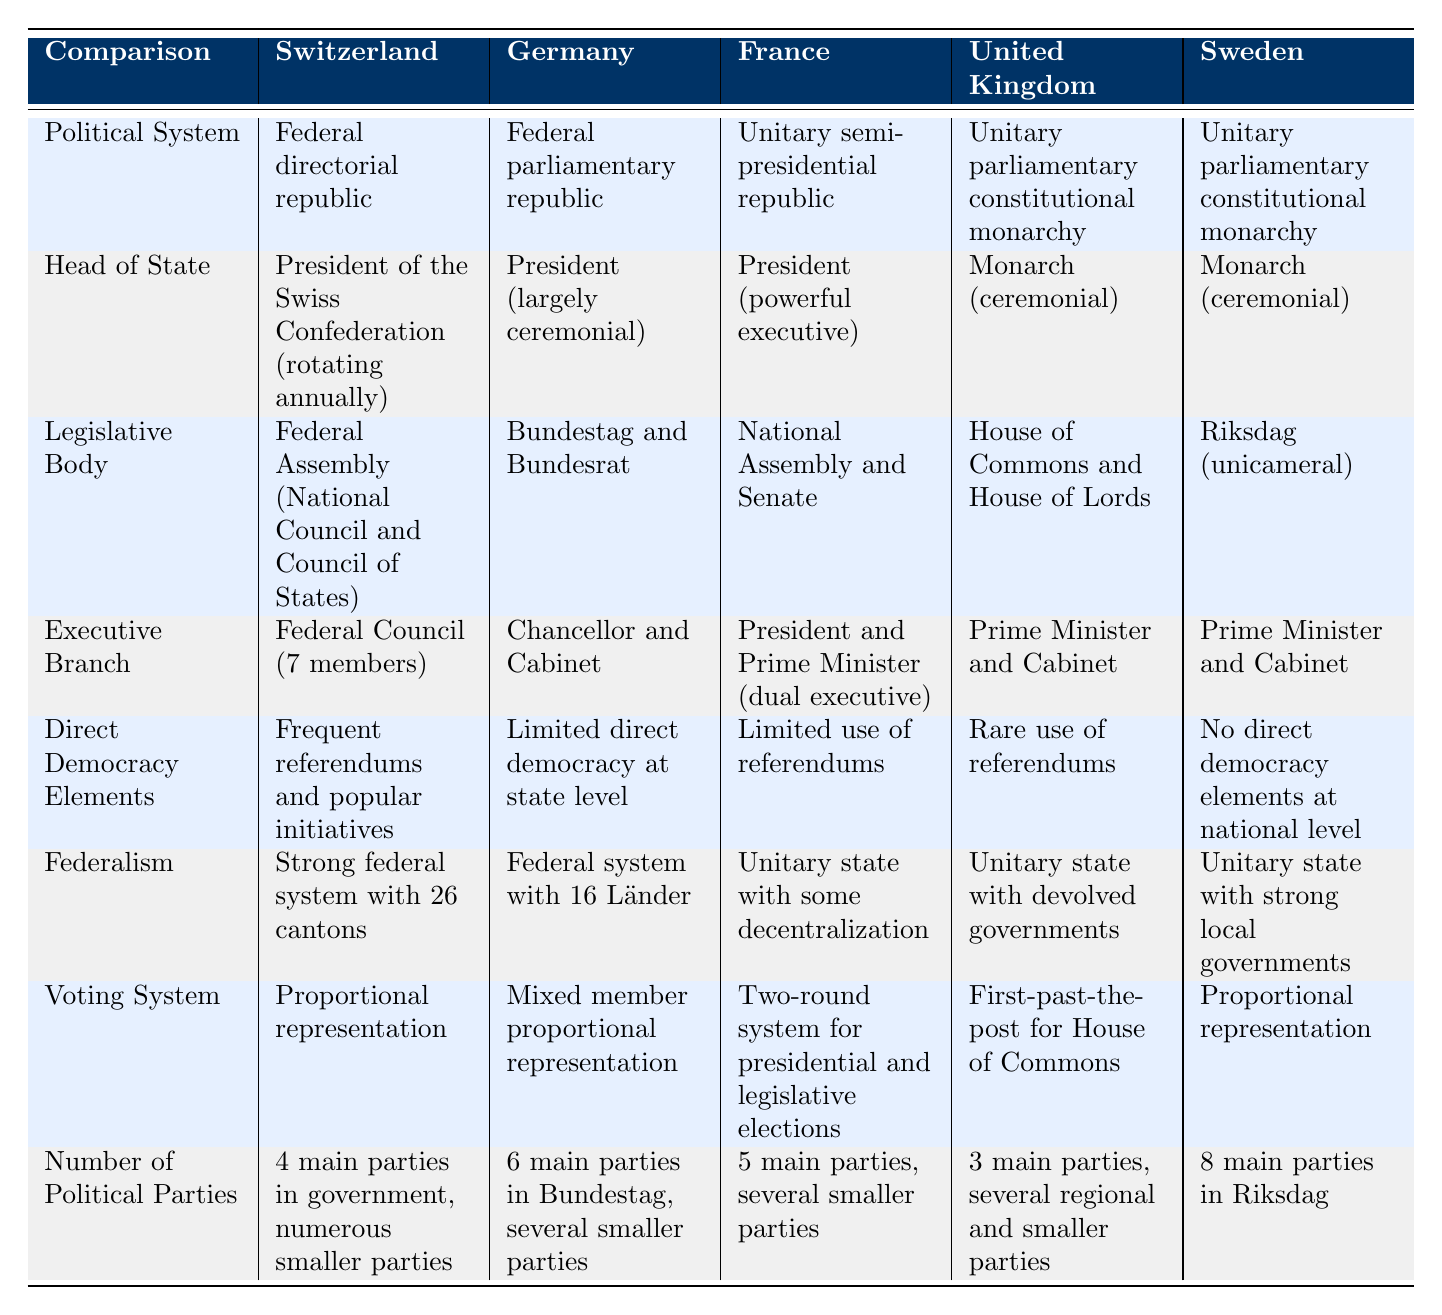What type of political system does Switzerland have? Switzerland has a "Federal directorial republic" as indicated in the table.
Answer: Federal directorial republic Which country has a powerful executive president? The table shows that "France" has a "President (powerful executive)" as its head of state.
Answer: France Is there direct democracy at the national level in Sweden? According to the table, Sweden has "No direct democracy elements at national level," indicating there is none.
Answer: No How many main political parties are present in Germany's Bundestag? The data states "6 main parties in Bundestag, several smaller parties" in the case of Germany.
Answer: 6 What is the difference in the number of political parties between Switzerland and the United Kingdom? Switzerland has "4 main parties in government," while the United Kingdom has "3 main parties." The difference is 4 - 3 = 1.
Answer: 1 Which country has the highest number of main parties according to the table? By checking the "Number of Political Parties" row, Sweden has "8 main parties in Riksdag," which is the highest among the listed countries.
Answer: Sweden Does Germany have a federal system? Yes, the table explicitly states that Germany has a "Federal system with 16 Länder," confirming it has a federal structure.
Answer: Yes What is the voting system used in Switzerland and how does it differ from that of the United Kingdom? Switzerland uses "Proportional representation," while the United Kingdom uses "First-past-the-post for House of Commons." This signifies a different methodology for determining election outcomes.
Answer: Different voting systems What elements of direct democracy are present in Switzerland compared to France? Switzerland has "Frequent referendums and popular initiatives," while France has "Limited use of referendums." This indicates that Switzerland employs more robust methods of direct democracy.
Answer: More robust in Switzerland 